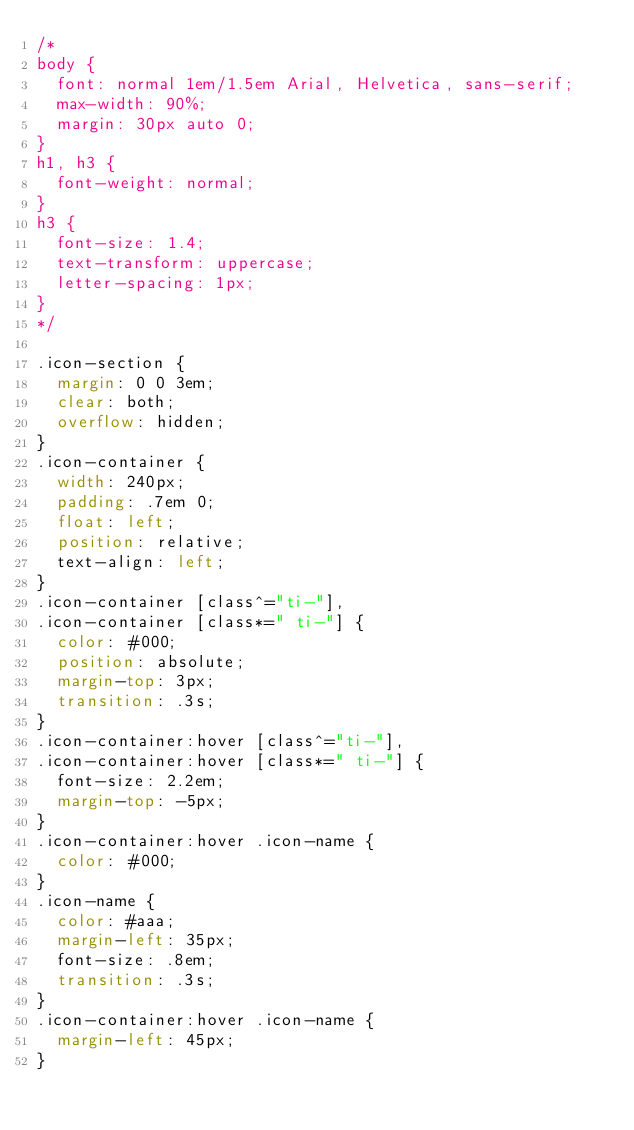Convert code to text. <code><loc_0><loc_0><loc_500><loc_500><_CSS_>/*
body {
	font: normal 1em/1.5em Arial, Helvetica, sans-serif;
	max-width: 90%;
	margin: 30px auto 0;
}
h1, h3 {
	font-weight: normal;
}
h3 {
	font-size: 1.4;
	text-transform: uppercase;
	letter-spacing: 1px;
}
*/

.icon-section {
	margin: 0 0 3em;
	clear: both;
	overflow: hidden;
}
.icon-container {
	width: 240px; 
	padding: .7em 0;
	float: left; 
	position: relative;
	text-align: left;
}
.icon-container [class^="ti-"], 
.icon-container [class*=" ti-"] {
	color: #000;
	position: absolute;
	margin-top: 3px;
	transition: .3s;
}
.icon-container:hover [class^="ti-"],
.icon-container:hover [class*=" ti-"] {
	font-size: 2.2em;
	margin-top: -5px;
}
.icon-container:hover .icon-name {
	color: #000;
}
.icon-name {
	color: #aaa;
	margin-left: 35px;
	font-size: .8em;
	transition: .3s;
}
.icon-container:hover .icon-name {
	margin-left: 45px;
}</code> 